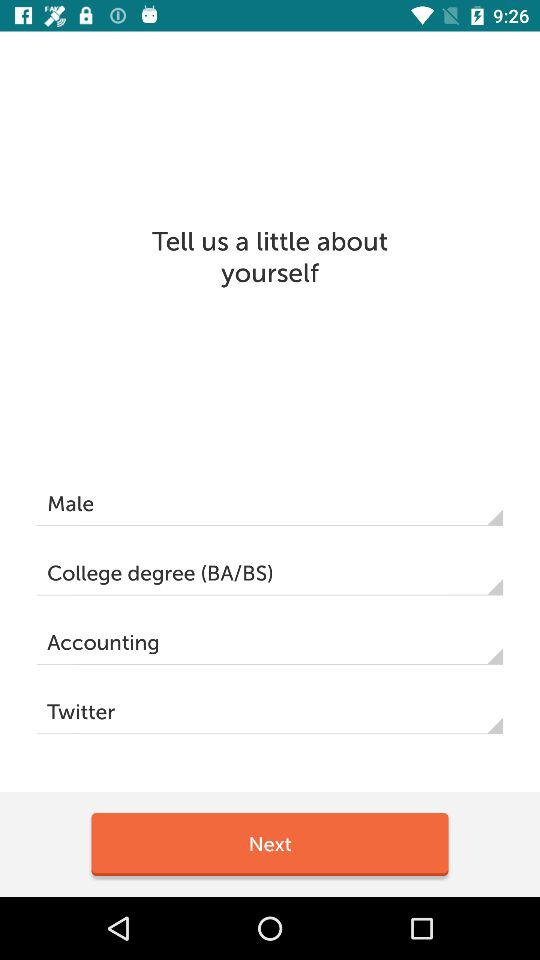What is the department? The department is accounting. 